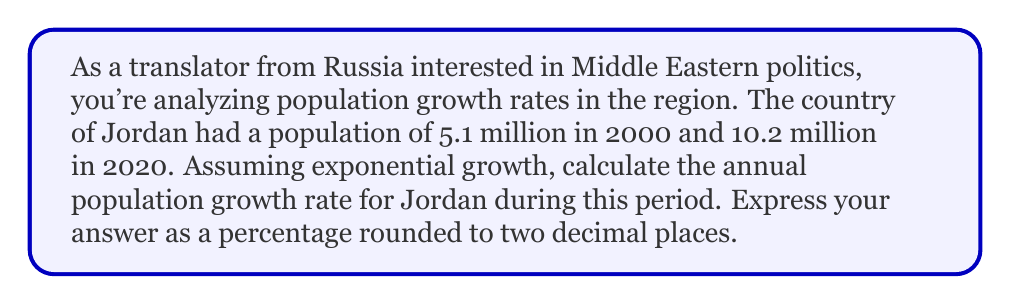Provide a solution to this math problem. To solve this problem, we'll use the exponential growth formula:

$$P(t) = P_0 \cdot e^{rt}$$

Where:
$P(t)$ is the population at time $t$
$P_0$ is the initial population
$r$ is the annual growth rate
$t$ is the time in years

We know:
$P_0 = 5.1$ million (population in 2000)
$P(t) = 10.2$ million (population in 2020)
$t = 20$ years

Let's substitute these values into the formula:

$$10.2 = 5.1 \cdot e^{20r}$$

Now, we need to solve for $r$:

1) Divide both sides by 5.1:
   $$\frac{10.2}{5.1} = e^{20r}$$

2) Take the natural logarithm of both sides:
   $$\ln(\frac{10.2}{5.1}) = 20r$$

3) Solve for $r$:
   $$r = \frac{\ln(\frac{10.2}{5.1})}{20}$$

4) Calculate the value:
   $$r = \frac{\ln(2)}{20} \approx 0.03466$$

5) Convert to a percentage:
   $$r \approx 3.466\%$$

6) Round to two decimal places:
   $$r \approx 3.47\%$$
Answer: 3.47% 